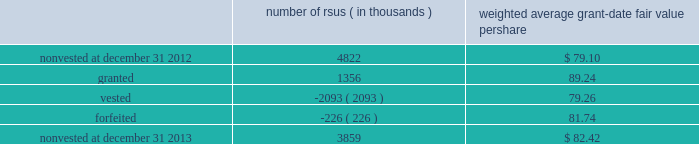Note 12 2013 stock-based compensation during 2013 , 2012 , and 2011 , we recorded non-cash stock-based compensation expense totaling $ 189 million , $ 167 million , and $ 157 million , which is included as a component of other unallocated costs on our statements of earnings .
The net impact to earnings for the respective years was $ 122 million , $ 108 million , and $ 101 million .
As of december 31 , 2013 , we had $ 132 million of unrecognized compensation cost related to nonvested awards , which is expected to be recognized over a weighted average period of 1.5 years .
We received cash from the exercise of stock options totaling $ 827 million , $ 440 million , and $ 116 million during 2013 , 2012 , and 2011 .
In addition , our income tax liabilities for 2013 , 2012 , and 2011 were reduced by $ 158 million , $ 96 million , and $ 56 million due to recognized tax benefits on stock-based compensation arrangements .
Stock-based compensation plans under plans approved by our stockholders , we are authorized to grant key employees stock-based incentive awards , including options to purchase common stock , stock appreciation rights , restricted stock units ( rsus ) , performance stock units ( psus ) , or other stock units .
The exercise price of options to purchase common stock may not be less than the fair market value of our stock on the date of grant .
No award of stock options may become fully vested prior to the third anniversary of the grant , and no portion of a stock option grant may become vested in less than one year .
The minimum vesting period for restricted stock or stock units payable in stock is three years .
Award agreements may provide for shorter or pro-rated vesting periods or vesting following termination of employment in the case of death , disability , divestiture , retirement , change of control , or layoff .
The maximum term of a stock option or any other award is 10 years .
At december 31 , 2013 , inclusive of the shares reserved for outstanding stock options , rsus and psus , we had 20.4 million shares reserved for issuance under the plans .
At december 31 , 2013 , 4.7 million of the shares reserved for issuance remained available for grant under our stock-based compensation plans .
We issue new shares upon the exercise of stock options or when restrictions on rsus and psus have been satisfied .
The table summarizes activity related to nonvested rsus during 2013 : number of rsus ( in thousands ) weighted average grant-date fair value per share .
Rsus are valued based on the fair value of our common stock on the date of grant .
Employees who are granted rsus receive the right to receive shares of stock after completion of the vesting period , however , the shares are not issued , and the employees cannot sell or transfer shares prior to vesting and have no voting rights until the rsus vest , generally three years from the date of the award .
Employees who are granted rsus receive dividend-equivalent cash payments only upon vesting .
For these rsu awards , the grant-date fair value is equal to the closing market price of our common stock on the date of grant less a discount to reflect the delay in payment of dividend-equivalent cash payments .
We recognize the grant-date fair value of rsus , less estimated forfeitures , as compensation expense ratably over the requisite service period , which beginning with the rsus granted in 2013 is shorter than the vesting period if the employee is retirement eligible on the date of grant or will become retirement eligible before the end of the vesting period .
Stock options we generally recognize compensation cost for stock options ratably over the three-year vesting period .
At december 31 , 2013 and 2012 , there were 10.2 million ( weighted average exercise price of $ 83.65 ) and 20.6 million ( weighted average exercise price of $ 83.15 ) stock options outstanding .
Stock options outstanding at december 31 , 2013 have a weighted average remaining contractual life of approximately five years and an aggregate intrinsic value of $ 663 million , and we expect nearly all of these stock options to vest .
Of the stock options outstanding , 7.7 million ( weighted average exercise price of $ 84.37 ) have vested as of december 31 , 2013 and those stock options have a weighted average remaining contractual life of approximately four years and an aggregate intrinsic value of $ 497 million .
There were 10.1 million ( weighted average exercise price of $ 82.72 ) stock options exercised during 2013 .
We did not grant stock options to employees during 2013. .
In 2013 what was the percentage change in the nonvested rsus? 
Computations: ((3859 - 4822) / 4822)
Answer: -0.19971. 